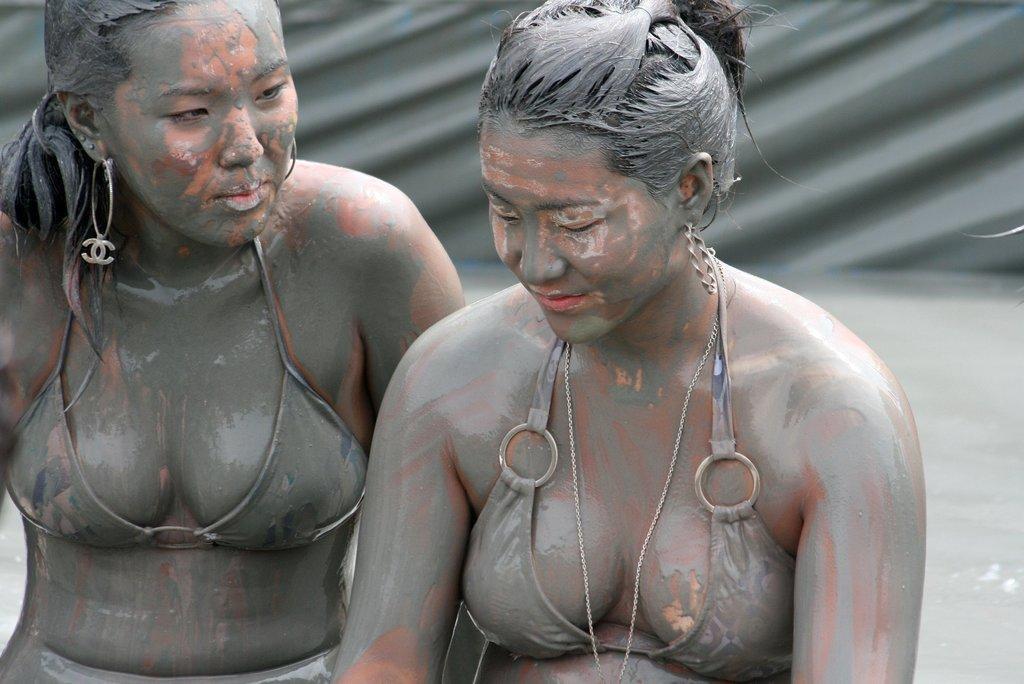Describe this image in one or two sentences. In this picture we can see two women, and also we can see mud. 